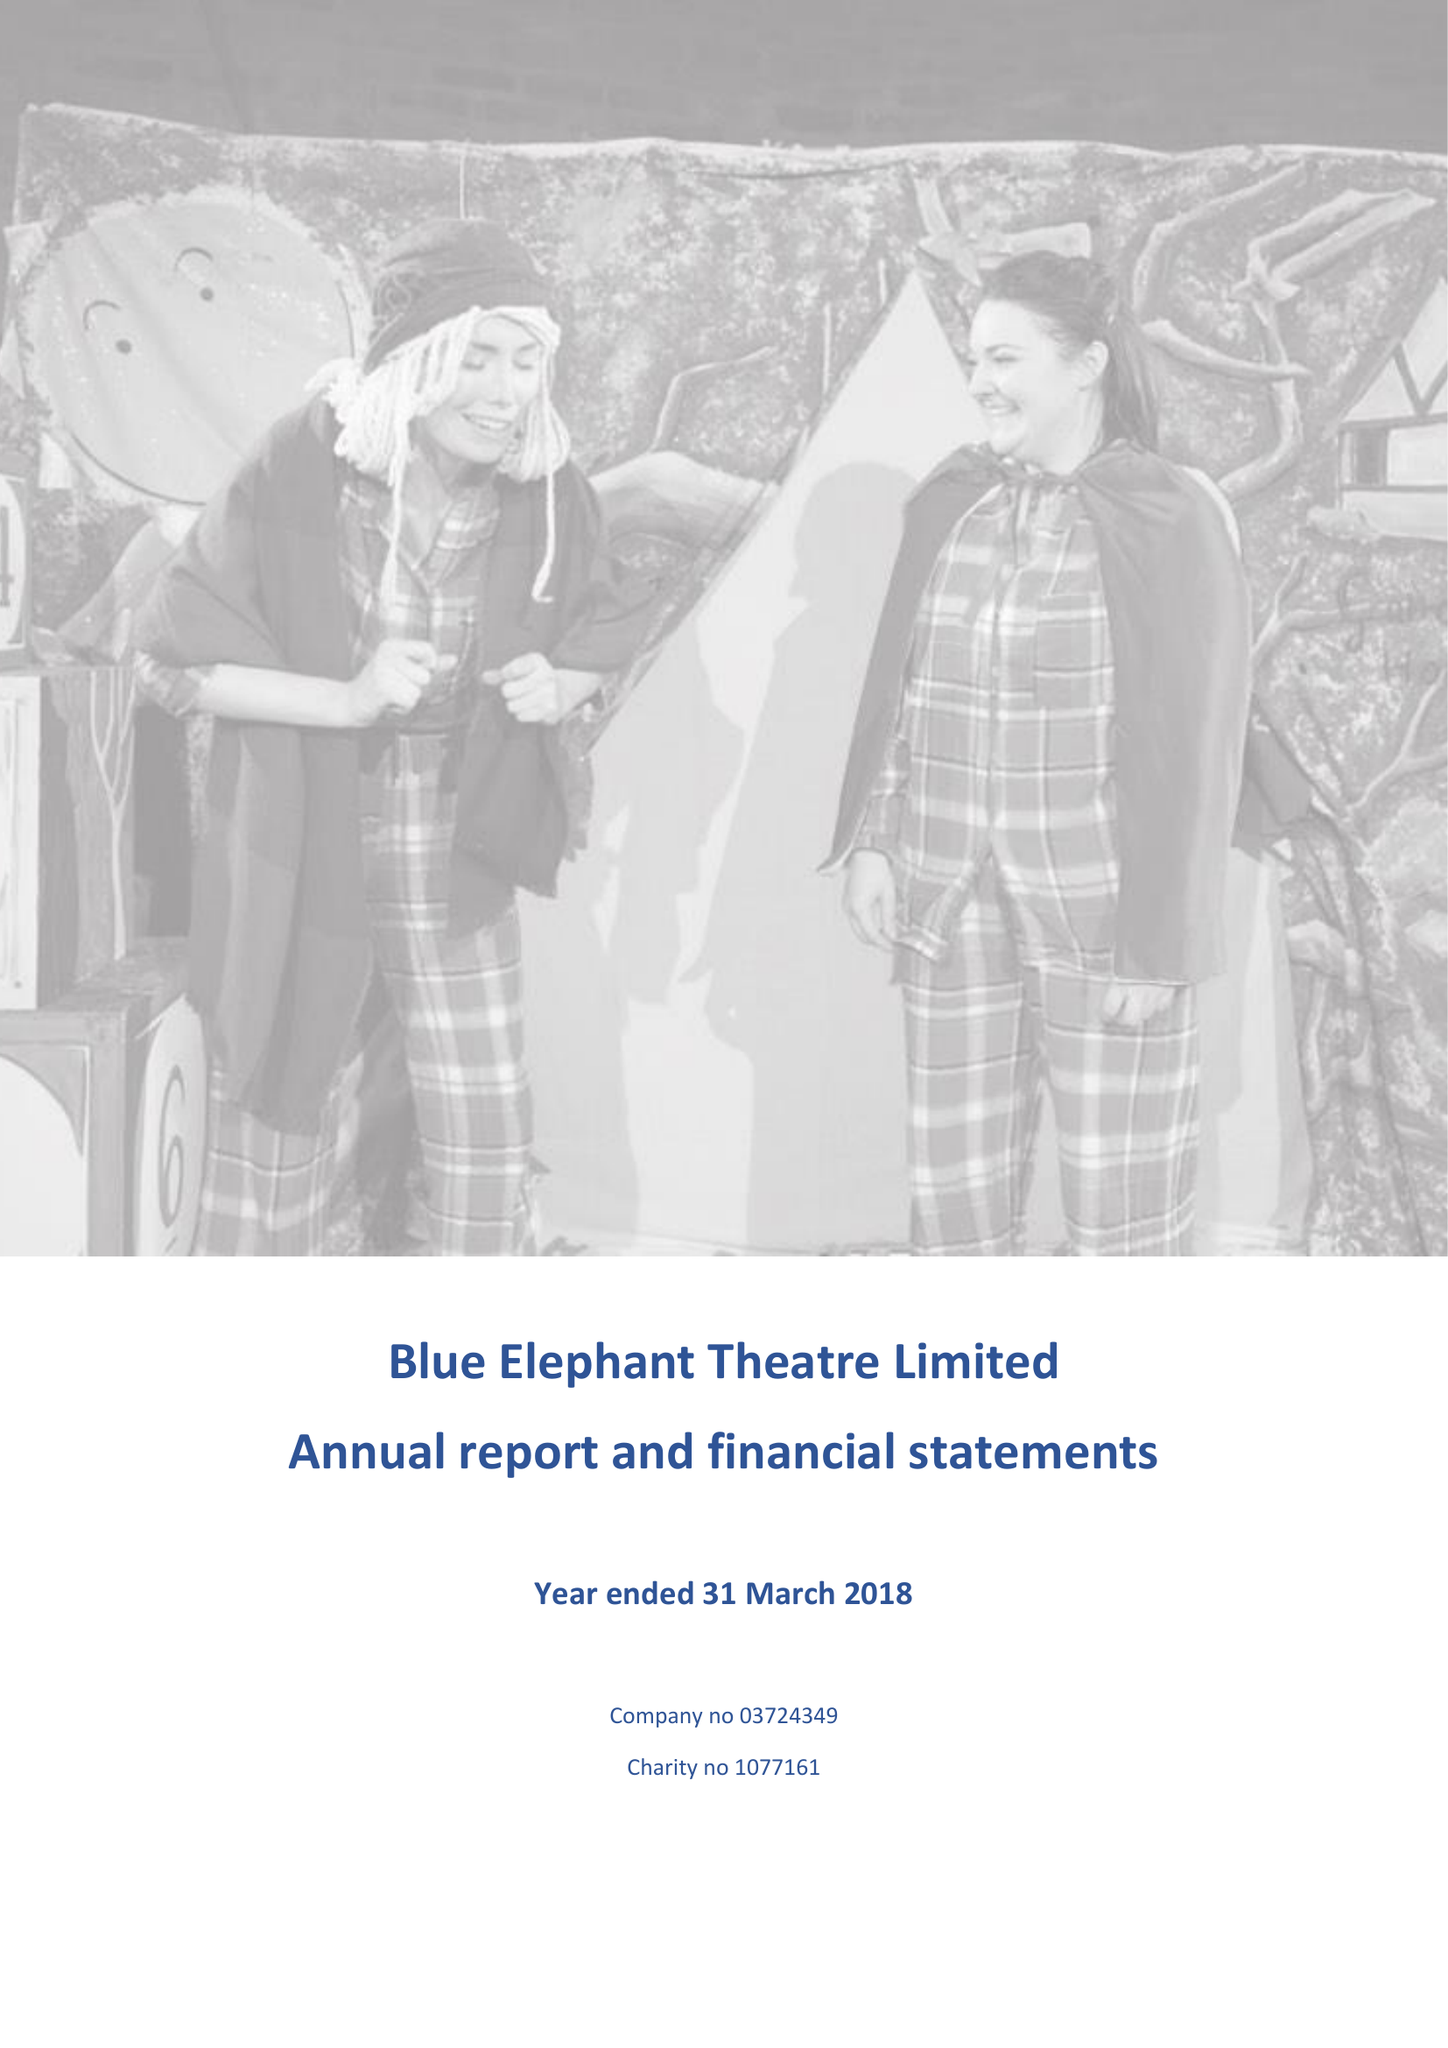What is the value for the address__street_line?
Answer the question using a single word or phrase. 59A BETHWIN ROAD 